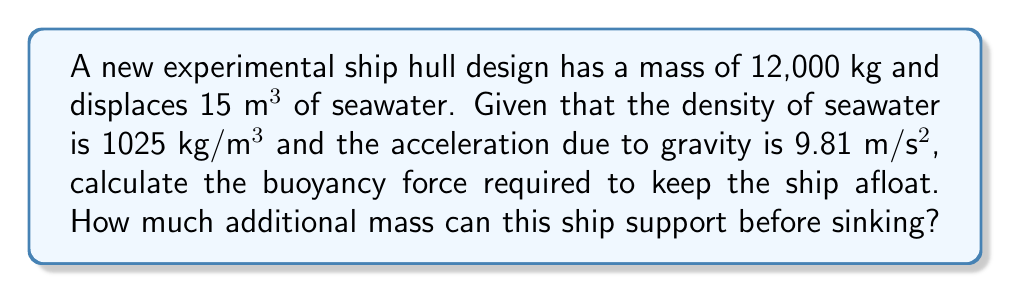Can you solve this math problem? 1. Calculate the buoyancy force:
   The buoyancy force is equal to the weight of the displaced fluid.
   $$F_b = \rho_{seawater} \cdot V_{displaced} \cdot g$$
   Where $\rho_{seawater}$ is the density of seawater, $V_{displaced}$ is the volume of displaced water, and $g$ is the acceleration due to gravity.
   
   $$F_b = 1025 \text{ kg/m³} \cdot 15 \text{ m³} \cdot 9.81 \text{ m/s²} = 150,778.125 \text{ N}$$

2. Calculate the weight of the ship:
   $$W_{ship} = m_{ship} \cdot g = 12,000 \text{ kg} \cdot 9.81 \text{ m/s²} = 117,720 \text{ N}$$

3. Calculate the additional weight the ship can support:
   $$W_{additional} = F_b - W_{ship} = 150,778.125 \text{ N} - 117,720 \text{ N} = 33,058.125 \text{ N}$$

4. Convert the additional weight to mass:
   $$m_{additional} = \frac{W_{additional}}{g} = \frac{33,058.125 \text{ N}}{9.81 \text{ m/s²}} = 3,369.84 \text{ kg}$$

Therefore, the buoyancy force required to keep the ship afloat is 150,778.125 N, and the ship can support an additional mass of 3,369.84 kg before sinking.
Answer: $F_b = 150,778.125 \text{ N}$; Additional mass = 3,369.84 kg 